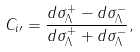Convert formula to latex. <formula><loc_0><loc_0><loc_500><loc_500>C _ { i \prime } = \frac { d \sigma _ { \Lambda } ^ { + } - d \sigma _ { \Lambda } ^ { - } } { d \sigma _ { \Lambda } ^ { + } + d \sigma _ { \Lambda } ^ { - } } ,</formula> 